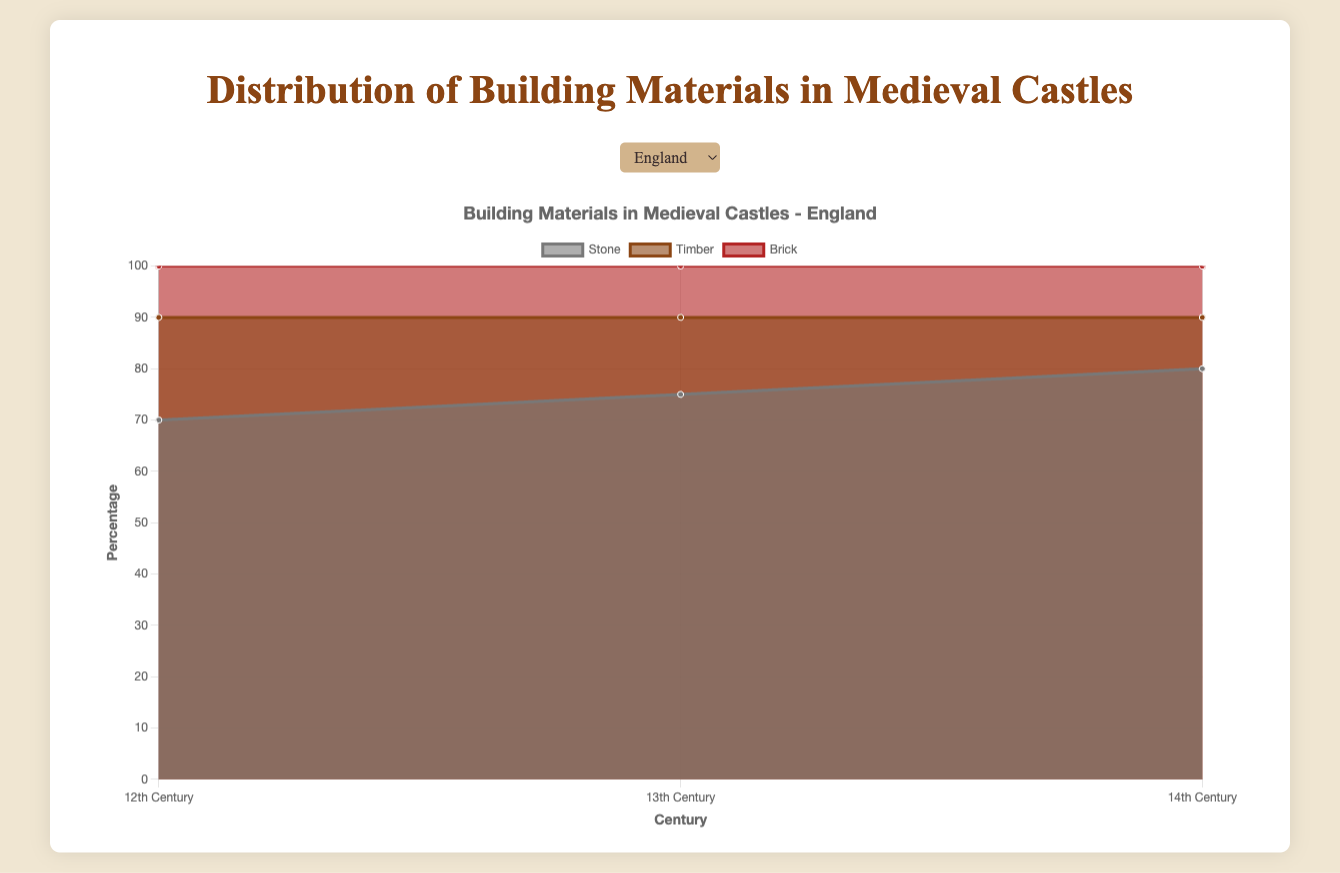What's the trend of stone usage in England from the 12th to the 14th century? Stone usage in England increases over time with 70% in the 12th century, 75% in the 13th century, and 80% in the 14th century.
Answer: Increases Which material had the highest percentage in France during the 12th century? In France, during the 12th century, stone had the highest percentage with 60%.
Answer: Stone Compare the percentage of timber in Germany and France during the 14th century. Which region had a higher percentage? In the 14th century, the timber percentage was 15% in Germany and 20% in France. France had a higher percentage.
Answer: France What is the total percentage of brick usage in England across all centuries shown? Brick usage in England has been consistent at 10% across the 12th, 13th, and 14th centuries. Summing these values gives 10% + 10% + 10% = 30%.
Answer: 30% Between which centuries did timber usage decrease the most in England? Timber usage in England dropped from 20% in the 12th century to 15% in the 13th century, a decrease of 5%. The drop continued to 10% in the 14th century, another 5% decrease. The decrease is the same for both transitions, from 12th to 13th and from 13th to 14th.
Answer: 12th to 13th, 13th to 14th What's the average percentage of stone usage across the three regions in the 13th century? Stone usage in the 13th century is 75% in England, 65% in France, and 70% in Germany. The average is (75 + 65 + 70) / 3 = 210 / 3 = 70%.
Answer: 70% Which region showed the least variation in brick usage across the centuries? All regions (England, France, and Germany) had a consistent brick usage of 10% across the 12th, 13th, and 14th centuries. There is no variation in any region.
Answer: All regions What specific trend is observable for timber usage in France over the observed periods? Timber usage in France shows a decreasing trend from 30% in the 12th century to 25% in the 13th century and 20% in the 14th century.
Answer: Decreases 